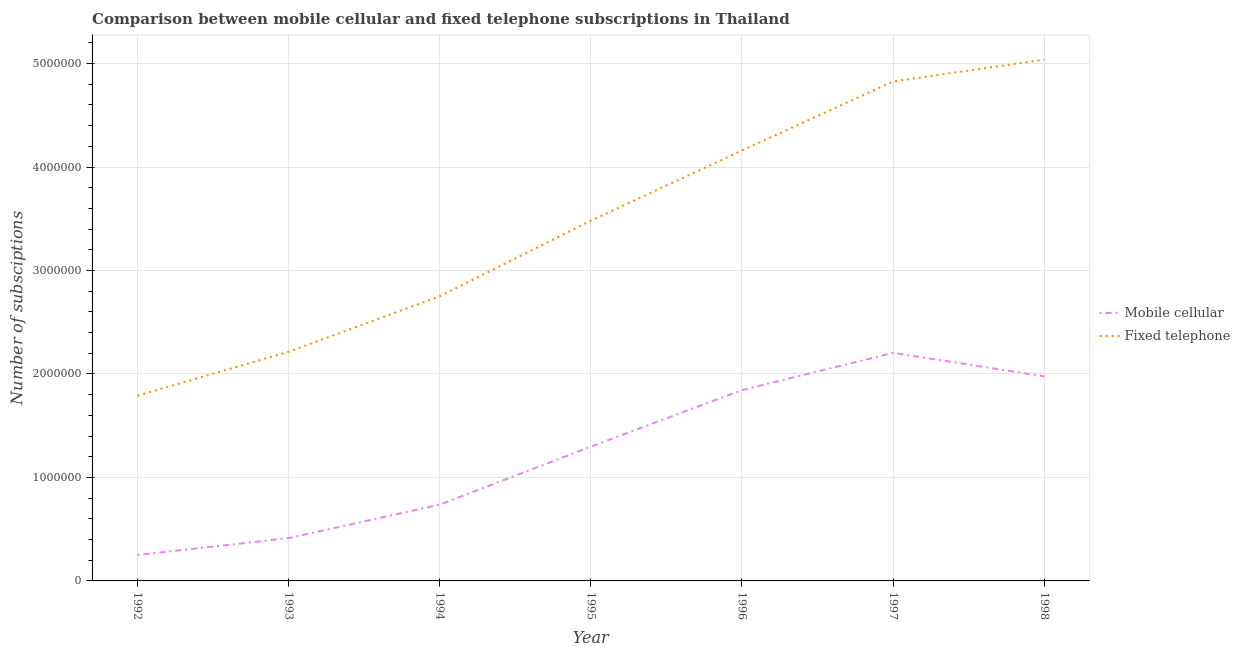How many different coloured lines are there?
Your answer should be very brief. 2. Does the line corresponding to number of fixed telephone subscriptions intersect with the line corresponding to number of mobile cellular subscriptions?
Give a very brief answer. No. Is the number of lines equal to the number of legend labels?
Provide a short and direct response. Yes. What is the number of mobile cellular subscriptions in 1995?
Your answer should be very brief. 1.30e+06. Across all years, what is the maximum number of mobile cellular subscriptions?
Provide a short and direct response. 2.20e+06. Across all years, what is the minimum number of fixed telephone subscriptions?
Your answer should be very brief. 1.79e+06. In which year was the number of mobile cellular subscriptions maximum?
Make the answer very short. 1997. What is the total number of mobile cellular subscriptions in the graph?
Your answer should be compact. 8.72e+06. What is the difference between the number of fixed telephone subscriptions in 1992 and that in 1997?
Offer a terse response. -3.04e+06. What is the difference between the number of fixed telephone subscriptions in 1993 and the number of mobile cellular subscriptions in 1995?
Ensure brevity in your answer.  9.17e+05. What is the average number of mobile cellular subscriptions per year?
Make the answer very short. 1.25e+06. In the year 1992, what is the difference between the number of fixed telephone subscriptions and number of mobile cellular subscriptions?
Your response must be concise. 1.54e+06. In how many years, is the number of mobile cellular subscriptions greater than 5000000?
Your answer should be very brief. 0. What is the ratio of the number of mobile cellular subscriptions in 1992 to that in 1998?
Keep it short and to the point. 0.13. What is the difference between the highest and the second highest number of mobile cellular subscriptions?
Ensure brevity in your answer.  2.27e+05. What is the difference between the highest and the lowest number of fixed telephone subscriptions?
Keep it short and to the point. 3.25e+06. In how many years, is the number of fixed telephone subscriptions greater than the average number of fixed telephone subscriptions taken over all years?
Give a very brief answer. 4. Does the number of mobile cellular subscriptions monotonically increase over the years?
Keep it short and to the point. No. What is the difference between two consecutive major ticks on the Y-axis?
Offer a very short reply. 1.00e+06. Are the values on the major ticks of Y-axis written in scientific E-notation?
Keep it short and to the point. No. Does the graph contain grids?
Provide a short and direct response. Yes. Where does the legend appear in the graph?
Offer a terse response. Center right. How many legend labels are there?
Keep it short and to the point. 2. How are the legend labels stacked?
Give a very brief answer. Vertical. What is the title of the graph?
Your answer should be compact. Comparison between mobile cellular and fixed telephone subscriptions in Thailand. Does "Methane" appear as one of the legend labels in the graph?
Your response must be concise. No. What is the label or title of the Y-axis?
Offer a very short reply. Number of subsciptions. What is the Number of subsciptions of Mobile cellular in 1992?
Your response must be concise. 2.51e+05. What is the Number of subsciptions in Fixed telephone in 1992?
Offer a very short reply. 1.79e+06. What is the Number of subsciptions of Mobile cellular in 1993?
Provide a short and direct response. 4.14e+05. What is the Number of subsciptions in Fixed telephone in 1993?
Keep it short and to the point. 2.21e+06. What is the Number of subsciptions of Mobile cellular in 1994?
Provide a short and direct response. 7.37e+05. What is the Number of subsciptions of Fixed telephone in 1994?
Your answer should be compact. 2.75e+06. What is the Number of subsciptions in Mobile cellular in 1995?
Ensure brevity in your answer.  1.30e+06. What is the Number of subsciptions in Fixed telephone in 1995?
Give a very brief answer. 3.48e+06. What is the Number of subsciptions of Mobile cellular in 1996?
Provide a short and direct response. 1.84e+06. What is the Number of subsciptions in Fixed telephone in 1996?
Offer a very short reply. 4.16e+06. What is the Number of subsciptions of Mobile cellular in 1997?
Provide a succinct answer. 2.20e+06. What is the Number of subsciptions in Fixed telephone in 1997?
Provide a short and direct response. 4.83e+06. What is the Number of subsciptions of Mobile cellular in 1998?
Give a very brief answer. 1.98e+06. What is the Number of subsciptions in Fixed telephone in 1998?
Offer a very short reply. 5.04e+06. Across all years, what is the maximum Number of subsciptions of Mobile cellular?
Your answer should be very brief. 2.20e+06. Across all years, what is the maximum Number of subsciptions of Fixed telephone?
Provide a succinct answer. 5.04e+06. Across all years, what is the minimum Number of subsciptions in Mobile cellular?
Offer a terse response. 2.51e+05. Across all years, what is the minimum Number of subsciptions of Fixed telephone?
Provide a succinct answer. 1.79e+06. What is the total Number of subsciptions of Mobile cellular in the graph?
Make the answer very short. 8.72e+06. What is the total Number of subsciptions of Fixed telephone in the graph?
Your answer should be very brief. 2.43e+07. What is the difference between the Number of subsciptions of Mobile cellular in 1992 and that in 1993?
Give a very brief answer. -1.63e+05. What is the difference between the Number of subsciptions of Fixed telephone in 1992 and that in 1993?
Ensure brevity in your answer.  -4.24e+05. What is the difference between the Number of subsciptions in Mobile cellular in 1992 and that in 1994?
Ensure brevity in your answer.  -4.87e+05. What is the difference between the Number of subsciptions in Fixed telephone in 1992 and that in 1994?
Your answer should be very brief. -9.61e+05. What is the difference between the Number of subsciptions of Mobile cellular in 1992 and that in 1995?
Your response must be concise. -1.05e+06. What is the difference between the Number of subsciptions of Fixed telephone in 1992 and that in 1995?
Give a very brief answer. -1.69e+06. What is the difference between the Number of subsciptions of Mobile cellular in 1992 and that in 1996?
Offer a very short reply. -1.59e+06. What is the difference between the Number of subsciptions of Fixed telephone in 1992 and that in 1996?
Provide a short and direct response. -2.37e+06. What is the difference between the Number of subsciptions in Mobile cellular in 1992 and that in 1997?
Provide a short and direct response. -1.95e+06. What is the difference between the Number of subsciptions of Fixed telephone in 1992 and that in 1997?
Give a very brief answer. -3.04e+06. What is the difference between the Number of subsciptions of Mobile cellular in 1992 and that in 1998?
Offer a very short reply. -1.73e+06. What is the difference between the Number of subsciptions in Fixed telephone in 1992 and that in 1998?
Offer a terse response. -3.25e+06. What is the difference between the Number of subsciptions of Mobile cellular in 1993 and that in 1994?
Provide a short and direct response. -3.24e+05. What is the difference between the Number of subsciptions of Fixed telephone in 1993 and that in 1994?
Offer a very short reply. -5.36e+05. What is the difference between the Number of subsciptions in Mobile cellular in 1993 and that in 1995?
Your response must be concise. -8.84e+05. What is the difference between the Number of subsciptions in Fixed telephone in 1993 and that in 1995?
Your response must be concise. -1.27e+06. What is the difference between the Number of subsciptions in Mobile cellular in 1993 and that in 1996?
Give a very brief answer. -1.43e+06. What is the difference between the Number of subsciptions in Fixed telephone in 1993 and that in 1996?
Provide a succinct answer. -1.95e+06. What is the difference between the Number of subsciptions in Mobile cellular in 1993 and that in 1997?
Offer a terse response. -1.79e+06. What is the difference between the Number of subsciptions of Fixed telephone in 1993 and that in 1997?
Offer a terse response. -2.61e+06. What is the difference between the Number of subsciptions in Mobile cellular in 1993 and that in 1998?
Provide a succinct answer. -1.56e+06. What is the difference between the Number of subsciptions in Fixed telephone in 1993 and that in 1998?
Your response must be concise. -2.82e+06. What is the difference between the Number of subsciptions of Mobile cellular in 1994 and that in 1995?
Your response must be concise. -5.61e+05. What is the difference between the Number of subsciptions of Fixed telephone in 1994 and that in 1995?
Your response must be concise. -7.31e+05. What is the difference between the Number of subsciptions in Mobile cellular in 1994 and that in 1996?
Provide a short and direct response. -1.11e+06. What is the difference between the Number of subsciptions in Fixed telephone in 1994 and that in 1996?
Your response must be concise. -1.41e+06. What is the difference between the Number of subsciptions of Mobile cellular in 1994 and that in 1997?
Your answer should be compact. -1.47e+06. What is the difference between the Number of subsciptions in Fixed telephone in 1994 and that in 1997?
Keep it short and to the point. -2.08e+06. What is the difference between the Number of subsciptions of Mobile cellular in 1994 and that in 1998?
Offer a very short reply. -1.24e+06. What is the difference between the Number of subsciptions in Fixed telephone in 1994 and that in 1998?
Your answer should be compact. -2.29e+06. What is the difference between the Number of subsciptions in Mobile cellular in 1995 and that in 1996?
Offer a terse response. -5.47e+05. What is the difference between the Number of subsciptions in Fixed telephone in 1995 and that in 1996?
Keep it short and to the point. -6.78e+05. What is the difference between the Number of subsciptions of Mobile cellular in 1995 and that in 1997?
Your response must be concise. -9.06e+05. What is the difference between the Number of subsciptions of Fixed telephone in 1995 and that in 1997?
Ensure brevity in your answer.  -1.34e+06. What is the difference between the Number of subsciptions of Mobile cellular in 1995 and that in 1998?
Your answer should be very brief. -6.79e+05. What is the difference between the Number of subsciptions of Fixed telephone in 1995 and that in 1998?
Your answer should be very brief. -1.56e+06. What is the difference between the Number of subsciptions of Mobile cellular in 1996 and that in 1997?
Give a very brief answer. -3.59e+05. What is the difference between the Number of subsciptions of Fixed telephone in 1996 and that in 1997?
Your response must be concise. -6.67e+05. What is the difference between the Number of subsciptions in Mobile cellular in 1996 and that in 1998?
Provide a succinct answer. -1.32e+05. What is the difference between the Number of subsciptions in Fixed telephone in 1996 and that in 1998?
Offer a very short reply. -8.77e+05. What is the difference between the Number of subsciptions in Mobile cellular in 1997 and that in 1998?
Your answer should be very brief. 2.27e+05. What is the difference between the Number of subsciptions in Fixed telephone in 1997 and that in 1998?
Your answer should be very brief. -2.11e+05. What is the difference between the Number of subsciptions of Mobile cellular in 1992 and the Number of subsciptions of Fixed telephone in 1993?
Offer a very short reply. -1.96e+06. What is the difference between the Number of subsciptions in Mobile cellular in 1992 and the Number of subsciptions in Fixed telephone in 1994?
Give a very brief answer. -2.50e+06. What is the difference between the Number of subsciptions in Mobile cellular in 1992 and the Number of subsciptions in Fixed telephone in 1995?
Your answer should be very brief. -3.23e+06. What is the difference between the Number of subsciptions in Mobile cellular in 1992 and the Number of subsciptions in Fixed telephone in 1996?
Ensure brevity in your answer.  -3.91e+06. What is the difference between the Number of subsciptions in Mobile cellular in 1992 and the Number of subsciptions in Fixed telephone in 1997?
Offer a very short reply. -4.58e+06. What is the difference between the Number of subsciptions of Mobile cellular in 1992 and the Number of subsciptions of Fixed telephone in 1998?
Your answer should be very brief. -4.79e+06. What is the difference between the Number of subsciptions in Mobile cellular in 1993 and the Number of subsciptions in Fixed telephone in 1994?
Your answer should be very brief. -2.34e+06. What is the difference between the Number of subsciptions of Mobile cellular in 1993 and the Number of subsciptions of Fixed telephone in 1995?
Give a very brief answer. -3.07e+06. What is the difference between the Number of subsciptions in Mobile cellular in 1993 and the Number of subsciptions in Fixed telephone in 1996?
Provide a succinct answer. -3.75e+06. What is the difference between the Number of subsciptions in Mobile cellular in 1993 and the Number of subsciptions in Fixed telephone in 1997?
Ensure brevity in your answer.  -4.41e+06. What is the difference between the Number of subsciptions of Mobile cellular in 1993 and the Number of subsciptions of Fixed telephone in 1998?
Give a very brief answer. -4.62e+06. What is the difference between the Number of subsciptions in Mobile cellular in 1994 and the Number of subsciptions in Fixed telephone in 1995?
Your response must be concise. -2.74e+06. What is the difference between the Number of subsciptions of Mobile cellular in 1994 and the Number of subsciptions of Fixed telephone in 1996?
Keep it short and to the point. -3.42e+06. What is the difference between the Number of subsciptions of Mobile cellular in 1994 and the Number of subsciptions of Fixed telephone in 1997?
Make the answer very short. -4.09e+06. What is the difference between the Number of subsciptions of Mobile cellular in 1994 and the Number of subsciptions of Fixed telephone in 1998?
Keep it short and to the point. -4.30e+06. What is the difference between the Number of subsciptions in Mobile cellular in 1995 and the Number of subsciptions in Fixed telephone in 1996?
Ensure brevity in your answer.  -2.86e+06. What is the difference between the Number of subsciptions of Mobile cellular in 1995 and the Number of subsciptions of Fixed telephone in 1997?
Provide a short and direct response. -3.53e+06. What is the difference between the Number of subsciptions of Mobile cellular in 1995 and the Number of subsciptions of Fixed telephone in 1998?
Keep it short and to the point. -3.74e+06. What is the difference between the Number of subsciptions of Mobile cellular in 1996 and the Number of subsciptions of Fixed telephone in 1997?
Provide a succinct answer. -2.98e+06. What is the difference between the Number of subsciptions of Mobile cellular in 1996 and the Number of subsciptions of Fixed telephone in 1998?
Give a very brief answer. -3.19e+06. What is the difference between the Number of subsciptions in Mobile cellular in 1997 and the Number of subsciptions in Fixed telephone in 1998?
Ensure brevity in your answer.  -2.83e+06. What is the average Number of subsciptions of Mobile cellular per year?
Offer a very short reply. 1.25e+06. What is the average Number of subsciptions of Fixed telephone per year?
Ensure brevity in your answer.  3.47e+06. In the year 1992, what is the difference between the Number of subsciptions in Mobile cellular and Number of subsciptions in Fixed telephone?
Your answer should be compact. -1.54e+06. In the year 1993, what is the difference between the Number of subsciptions in Mobile cellular and Number of subsciptions in Fixed telephone?
Your response must be concise. -1.80e+06. In the year 1994, what is the difference between the Number of subsciptions in Mobile cellular and Number of subsciptions in Fixed telephone?
Your response must be concise. -2.01e+06. In the year 1995, what is the difference between the Number of subsciptions in Mobile cellular and Number of subsciptions in Fixed telephone?
Offer a terse response. -2.18e+06. In the year 1996, what is the difference between the Number of subsciptions of Mobile cellular and Number of subsciptions of Fixed telephone?
Offer a very short reply. -2.32e+06. In the year 1997, what is the difference between the Number of subsciptions in Mobile cellular and Number of subsciptions in Fixed telephone?
Your answer should be compact. -2.62e+06. In the year 1998, what is the difference between the Number of subsciptions in Mobile cellular and Number of subsciptions in Fixed telephone?
Offer a very short reply. -3.06e+06. What is the ratio of the Number of subsciptions of Mobile cellular in 1992 to that in 1993?
Your answer should be compact. 0.61. What is the ratio of the Number of subsciptions of Fixed telephone in 1992 to that in 1993?
Your answer should be very brief. 0.81. What is the ratio of the Number of subsciptions of Mobile cellular in 1992 to that in 1994?
Keep it short and to the point. 0.34. What is the ratio of the Number of subsciptions of Fixed telephone in 1992 to that in 1994?
Keep it short and to the point. 0.65. What is the ratio of the Number of subsciptions of Mobile cellular in 1992 to that in 1995?
Your response must be concise. 0.19. What is the ratio of the Number of subsciptions in Fixed telephone in 1992 to that in 1995?
Keep it short and to the point. 0.51. What is the ratio of the Number of subsciptions in Mobile cellular in 1992 to that in 1996?
Your response must be concise. 0.14. What is the ratio of the Number of subsciptions of Fixed telephone in 1992 to that in 1996?
Make the answer very short. 0.43. What is the ratio of the Number of subsciptions in Mobile cellular in 1992 to that in 1997?
Give a very brief answer. 0.11. What is the ratio of the Number of subsciptions in Fixed telephone in 1992 to that in 1997?
Offer a very short reply. 0.37. What is the ratio of the Number of subsciptions in Mobile cellular in 1992 to that in 1998?
Make the answer very short. 0.13. What is the ratio of the Number of subsciptions in Fixed telephone in 1992 to that in 1998?
Give a very brief answer. 0.36. What is the ratio of the Number of subsciptions in Mobile cellular in 1993 to that in 1994?
Your answer should be compact. 0.56. What is the ratio of the Number of subsciptions of Fixed telephone in 1993 to that in 1994?
Provide a succinct answer. 0.81. What is the ratio of the Number of subsciptions in Mobile cellular in 1993 to that in 1995?
Your answer should be very brief. 0.32. What is the ratio of the Number of subsciptions in Fixed telephone in 1993 to that in 1995?
Your response must be concise. 0.64. What is the ratio of the Number of subsciptions of Mobile cellular in 1993 to that in 1996?
Provide a succinct answer. 0.22. What is the ratio of the Number of subsciptions in Fixed telephone in 1993 to that in 1996?
Offer a terse response. 0.53. What is the ratio of the Number of subsciptions of Mobile cellular in 1993 to that in 1997?
Make the answer very short. 0.19. What is the ratio of the Number of subsciptions of Fixed telephone in 1993 to that in 1997?
Make the answer very short. 0.46. What is the ratio of the Number of subsciptions of Mobile cellular in 1993 to that in 1998?
Your answer should be very brief. 0.21. What is the ratio of the Number of subsciptions of Fixed telephone in 1993 to that in 1998?
Your answer should be very brief. 0.44. What is the ratio of the Number of subsciptions in Mobile cellular in 1994 to that in 1995?
Offer a terse response. 0.57. What is the ratio of the Number of subsciptions in Fixed telephone in 1994 to that in 1995?
Offer a terse response. 0.79. What is the ratio of the Number of subsciptions in Mobile cellular in 1994 to that in 1996?
Provide a succinct answer. 0.4. What is the ratio of the Number of subsciptions of Fixed telephone in 1994 to that in 1996?
Provide a succinct answer. 0.66. What is the ratio of the Number of subsciptions in Mobile cellular in 1994 to that in 1997?
Provide a succinct answer. 0.33. What is the ratio of the Number of subsciptions of Fixed telephone in 1994 to that in 1997?
Offer a very short reply. 0.57. What is the ratio of the Number of subsciptions in Mobile cellular in 1994 to that in 1998?
Provide a short and direct response. 0.37. What is the ratio of the Number of subsciptions in Fixed telephone in 1994 to that in 1998?
Provide a short and direct response. 0.55. What is the ratio of the Number of subsciptions of Mobile cellular in 1995 to that in 1996?
Your answer should be compact. 0.7. What is the ratio of the Number of subsciptions of Fixed telephone in 1995 to that in 1996?
Keep it short and to the point. 0.84. What is the ratio of the Number of subsciptions of Mobile cellular in 1995 to that in 1997?
Make the answer very short. 0.59. What is the ratio of the Number of subsciptions of Fixed telephone in 1995 to that in 1997?
Offer a very short reply. 0.72. What is the ratio of the Number of subsciptions of Mobile cellular in 1995 to that in 1998?
Your answer should be compact. 0.66. What is the ratio of the Number of subsciptions in Fixed telephone in 1995 to that in 1998?
Offer a terse response. 0.69. What is the ratio of the Number of subsciptions in Mobile cellular in 1996 to that in 1997?
Provide a succinct answer. 0.84. What is the ratio of the Number of subsciptions in Fixed telephone in 1996 to that in 1997?
Provide a short and direct response. 0.86. What is the ratio of the Number of subsciptions of Mobile cellular in 1996 to that in 1998?
Keep it short and to the point. 0.93. What is the ratio of the Number of subsciptions of Fixed telephone in 1996 to that in 1998?
Your answer should be compact. 0.83. What is the ratio of the Number of subsciptions of Mobile cellular in 1997 to that in 1998?
Your answer should be compact. 1.11. What is the ratio of the Number of subsciptions in Fixed telephone in 1997 to that in 1998?
Your answer should be very brief. 0.96. What is the difference between the highest and the second highest Number of subsciptions in Mobile cellular?
Give a very brief answer. 2.27e+05. What is the difference between the highest and the second highest Number of subsciptions of Fixed telephone?
Ensure brevity in your answer.  2.11e+05. What is the difference between the highest and the lowest Number of subsciptions of Mobile cellular?
Your response must be concise. 1.95e+06. What is the difference between the highest and the lowest Number of subsciptions of Fixed telephone?
Provide a short and direct response. 3.25e+06. 